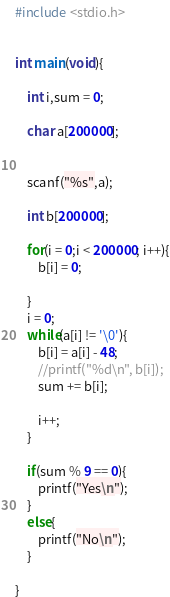<code> <loc_0><loc_0><loc_500><loc_500><_C_>#include <stdio.h>

 
int main(void){
 
    int i,sum = 0;
    
    char a[200000];
 
    
    scanf("%s",a);
    
    int b[200000];
    
    for(i = 0;i < 200000; i++){
        b[i] = 0;
    
    }
    i = 0;
    while(a[i] != '\0'){
        b[i] = a[i] - 48;
		//printf("%d\n", b[i]);
		sum += b[i];
		
		i++;
	}
	
	if(sum % 9 == 0){
	    printf("Yes\n");
	}
	else{
	    printf("No\n");
	}
	
}</code> 